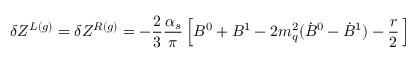<formula> <loc_0><loc_0><loc_500><loc_500>\delta Z ^ { L ( g ) } = \delta Z ^ { R ( g ) } = - \frac { 2 } { 3 } \frac { \alpha _ { s } } { \pi } \left [ B ^ { 0 } + B ^ { 1 } - 2 m _ { q } ^ { 2 } ( { \dot { B } } ^ { 0 } - { \dot { B } } ^ { 1 } ) - \frac { r } { 2 } \, \right ]</formula> 